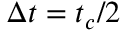Convert formula to latex. <formula><loc_0><loc_0><loc_500><loc_500>\Delta t = t _ { c } / 2</formula> 